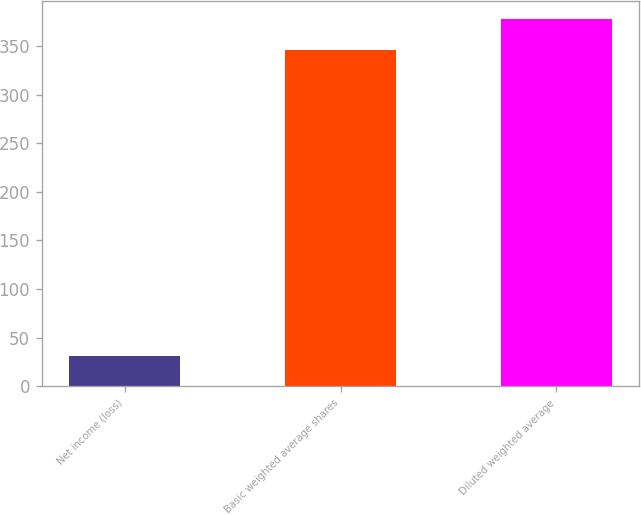Convert chart. <chart><loc_0><loc_0><loc_500><loc_500><bar_chart><fcel>Net income (loss)<fcel>Basic weighted average shares<fcel>Diluted weighted average<nl><fcel>31<fcel>346<fcel>377.5<nl></chart> 